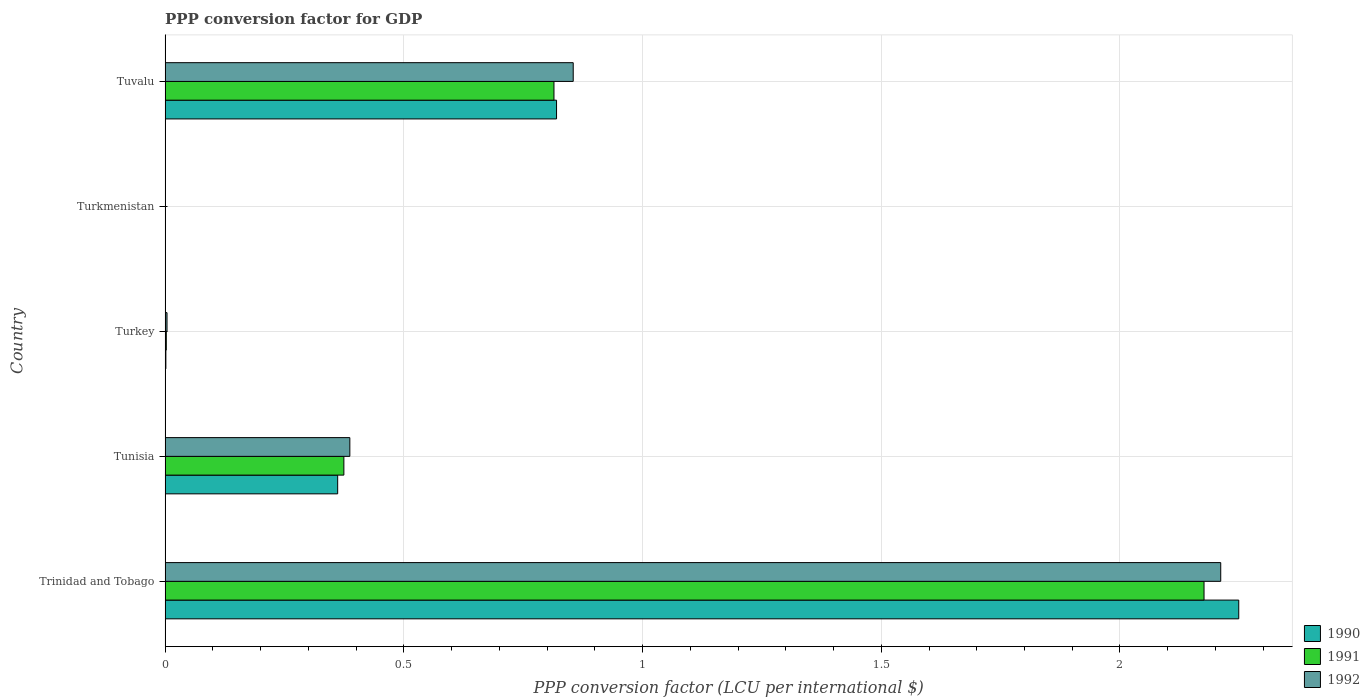How many different coloured bars are there?
Offer a very short reply. 3. Are the number of bars on each tick of the Y-axis equal?
Your answer should be very brief. Yes. How many bars are there on the 2nd tick from the top?
Ensure brevity in your answer.  3. What is the label of the 3rd group of bars from the top?
Make the answer very short. Turkey. What is the PPP conversion factor for GDP in 1991 in Tuvalu?
Ensure brevity in your answer.  0.81. Across all countries, what is the maximum PPP conversion factor for GDP in 1990?
Your response must be concise. 2.25. Across all countries, what is the minimum PPP conversion factor for GDP in 1990?
Provide a short and direct response. 1.53509362101671e-7. In which country was the PPP conversion factor for GDP in 1992 maximum?
Offer a terse response. Trinidad and Tobago. In which country was the PPP conversion factor for GDP in 1991 minimum?
Offer a very short reply. Turkmenistan. What is the total PPP conversion factor for GDP in 1991 in the graph?
Ensure brevity in your answer.  3.37. What is the difference between the PPP conversion factor for GDP in 1992 in Trinidad and Tobago and that in Turkmenistan?
Keep it short and to the point. 2.21. What is the difference between the PPP conversion factor for GDP in 1992 in Turkmenistan and the PPP conversion factor for GDP in 1990 in Turkey?
Provide a short and direct response. -0. What is the average PPP conversion factor for GDP in 1992 per country?
Offer a very short reply. 0.69. What is the difference between the PPP conversion factor for GDP in 1990 and PPP conversion factor for GDP in 1991 in Trinidad and Tobago?
Ensure brevity in your answer.  0.07. In how many countries, is the PPP conversion factor for GDP in 1991 greater than 1.5 LCU?
Give a very brief answer. 1. What is the ratio of the PPP conversion factor for GDP in 1991 in Trinidad and Tobago to that in Turkmenistan?
Ensure brevity in your answer.  7.22e+06. Is the PPP conversion factor for GDP in 1990 in Trinidad and Tobago less than that in Turkmenistan?
Make the answer very short. No. Is the difference between the PPP conversion factor for GDP in 1990 in Trinidad and Tobago and Tunisia greater than the difference between the PPP conversion factor for GDP in 1991 in Trinidad and Tobago and Tunisia?
Provide a succinct answer. Yes. What is the difference between the highest and the second highest PPP conversion factor for GDP in 1992?
Make the answer very short. 1.36. What is the difference between the highest and the lowest PPP conversion factor for GDP in 1991?
Make the answer very short. 2.18. In how many countries, is the PPP conversion factor for GDP in 1992 greater than the average PPP conversion factor for GDP in 1992 taken over all countries?
Offer a very short reply. 2. Is the sum of the PPP conversion factor for GDP in 1991 in Trinidad and Tobago and Turkmenistan greater than the maximum PPP conversion factor for GDP in 1990 across all countries?
Your answer should be very brief. No. What does the 1st bar from the top in Trinidad and Tobago represents?
Your answer should be compact. 1992. What does the 1st bar from the bottom in Trinidad and Tobago represents?
Offer a very short reply. 1990. How many bars are there?
Give a very brief answer. 15. Are all the bars in the graph horizontal?
Offer a very short reply. Yes. What is the difference between two consecutive major ticks on the X-axis?
Keep it short and to the point. 0.5. Are the values on the major ticks of X-axis written in scientific E-notation?
Provide a succinct answer. No. How are the legend labels stacked?
Give a very brief answer. Vertical. What is the title of the graph?
Offer a very short reply. PPP conversion factor for GDP. Does "1998" appear as one of the legend labels in the graph?
Ensure brevity in your answer.  No. What is the label or title of the X-axis?
Offer a terse response. PPP conversion factor (LCU per international $). What is the label or title of the Y-axis?
Your answer should be compact. Country. What is the PPP conversion factor (LCU per international $) in 1990 in Trinidad and Tobago?
Offer a very short reply. 2.25. What is the PPP conversion factor (LCU per international $) in 1991 in Trinidad and Tobago?
Offer a very short reply. 2.18. What is the PPP conversion factor (LCU per international $) of 1992 in Trinidad and Tobago?
Offer a very short reply. 2.21. What is the PPP conversion factor (LCU per international $) in 1990 in Tunisia?
Your response must be concise. 0.36. What is the PPP conversion factor (LCU per international $) of 1991 in Tunisia?
Provide a short and direct response. 0.37. What is the PPP conversion factor (LCU per international $) of 1992 in Tunisia?
Keep it short and to the point. 0.39. What is the PPP conversion factor (LCU per international $) of 1990 in Turkey?
Provide a succinct answer. 0. What is the PPP conversion factor (LCU per international $) of 1991 in Turkey?
Offer a terse response. 0. What is the PPP conversion factor (LCU per international $) of 1992 in Turkey?
Offer a very short reply. 0. What is the PPP conversion factor (LCU per international $) of 1990 in Turkmenistan?
Make the answer very short. 1.53509362101671e-7. What is the PPP conversion factor (LCU per international $) of 1991 in Turkmenistan?
Your response must be concise. 3.01227082389115e-7. What is the PPP conversion factor (LCU per international $) in 1992 in Turkmenistan?
Your answer should be compact. 9.4244319432505e-6. What is the PPP conversion factor (LCU per international $) in 1990 in Tuvalu?
Your answer should be compact. 0.82. What is the PPP conversion factor (LCU per international $) in 1991 in Tuvalu?
Give a very brief answer. 0.81. What is the PPP conversion factor (LCU per international $) of 1992 in Tuvalu?
Your response must be concise. 0.85. Across all countries, what is the maximum PPP conversion factor (LCU per international $) in 1990?
Provide a succinct answer. 2.25. Across all countries, what is the maximum PPP conversion factor (LCU per international $) of 1991?
Make the answer very short. 2.18. Across all countries, what is the maximum PPP conversion factor (LCU per international $) in 1992?
Provide a short and direct response. 2.21. Across all countries, what is the minimum PPP conversion factor (LCU per international $) of 1990?
Ensure brevity in your answer.  1.53509362101671e-7. Across all countries, what is the minimum PPP conversion factor (LCU per international $) in 1991?
Offer a terse response. 3.01227082389115e-7. Across all countries, what is the minimum PPP conversion factor (LCU per international $) in 1992?
Provide a succinct answer. 9.4244319432505e-6. What is the total PPP conversion factor (LCU per international $) of 1990 in the graph?
Your response must be concise. 3.43. What is the total PPP conversion factor (LCU per international $) in 1991 in the graph?
Offer a very short reply. 3.37. What is the total PPP conversion factor (LCU per international $) in 1992 in the graph?
Make the answer very short. 3.46. What is the difference between the PPP conversion factor (LCU per international $) in 1990 in Trinidad and Tobago and that in Tunisia?
Give a very brief answer. 1.89. What is the difference between the PPP conversion factor (LCU per international $) in 1991 in Trinidad and Tobago and that in Tunisia?
Provide a succinct answer. 1.8. What is the difference between the PPP conversion factor (LCU per international $) of 1992 in Trinidad and Tobago and that in Tunisia?
Your response must be concise. 1.82. What is the difference between the PPP conversion factor (LCU per international $) in 1990 in Trinidad and Tobago and that in Turkey?
Provide a succinct answer. 2.25. What is the difference between the PPP conversion factor (LCU per international $) in 1991 in Trinidad and Tobago and that in Turkey?
Your answer should be compact. 2.17. What is the difference between the PPP conversion factor (LCU per international $) of 1992 in Trinidad and Tobago and that in Turkey?
Offer a terse response. 2.21. What is the difference between the PPP conversion factor (LCU per international $) in 1990 in Trinidad and Tobago and that in Turkmenistan?
Offer a terse response. 2.25. What is the difference between the PPP conversion factor (LCU per international $) of 1991 in Trinidad and Tobago and that in Turkmenistan?
Give a very brief answer. 2.18. What is the difference between the PPP conversion factor (LCU per international $) of 1992 in Trinidad and Tobago and that in Turkmenistan?
Your answer should be compact. 2.21. What is the difference between the PPP conversion factor (LCU per international $) of 1990 in Trinidad and Tobago and that in Tuvalu?
Provide a short and direct response. 1.43. What is the difference between the PPP conversion factor (LCU per international $) in 1991 in Trinidad and Tobago and that in Tuvalu?
Give a very brief answer. 1.36. What is the difference between the PPP conversion factor (LCU per international $) in 1992 in Trinidad and Tobago and that in Tuvalu?
Offer a very short reply. 1.36. What is the difference between the PPP conversion factor (LCU per international $) of 1990 in Tunisia and that in Turkey?
Your answer should be very brief. 0.36. What is the difference between the PPP conversion factor (LCU per international $) in 1991 in Tunisia and that in Turkey?
Your answer should be compact. 0.37. What is the difference between the PPP conversion factor (LCU per international $) of 1992 in Tunisia and that in Turkey?
Offer a very short reply. 0.38. What is the difference between the PPP conversion factor (LCU per international $) in 1990 in Tunisia and that in Turkmenistan?
Provide a short and direct response. 0.36. What is the difference between the PPP conversion factor (LCU per international $) in 1991 in Tunisia and that in Turkmenistan?
Offer a terse response. 0.37. What is the difference between the PPP conversion factor (LCU per international $) in 1992 in Tunisia and that in Turkmenistan?
Offer a terse response. 0.39. What is the difference between the PPP conversion factor (LCU per international $) of 1990 in Tunisia and that in Tuvalu?
Give a very brief answer. -0.46. What is the difference between the PPP conversion factor (LCU per international $) of 1991 in Tunisia and that in Tuvalu?
Your answer should be compact. -0.44. What is the difference between the PPP conversion factor (LCU per international $) in 1992 in Tunisia and that in Tuvalu?
Give a very brief answer. -0.47. What is the difference between the PPP conversion factor (LCU per international $) in 1990 in Turkey and that in Turkmenistan?
Offer a terse response. 0. What is the difference between the PPP conversion factor (LCU per international $) of 1991 in Turkey and that in Turkmenistan?
Make the answer very short. 0. What is the difference between the PPP conversion factor (LCU per international $) in 1992 in Turkey and that in Turkmenistan?
Ensure brevity in your answer.  0. What is the difference between the PPP conversion factor (LCU per international $) in 1990 in Turkey and that in Tuvalu?
Give a very brief answer. -0.82. What is the difference between the PPP conversion factor (LCU per international $) in 1991 in Turkey and that in Tuvalu?
Provide a succinct answer. -0.81. What is the difference between the PPP conversion factor (LCU per international $) of 1992 in Turkey and that in Tuvalu?
Give a very brief answer. -0.85. What is the difference between the PPP conversion factor (LCU per international $) in 1990 in Turkmenistan and that in Tuvalu?
Provide a succinct answer. -0.82. What is the difference between the PPP conversion factor (LCU per international $) in 1991 in Turkmenistan and that in Tuvalu?
Your answer should be very brief. -0.81. What is the difference between the PPP conversion factor (LCU per international $) in 1992 in Turkmenistan and that in Tuvalu?
Offer a terse response. -0.85. What is the difference between the PPP conversion factor (LCU per international $) in 1990 in Trinidad and Tobago and the PPP conversion factor (LCU per international $) in 1991 in Tunisia?
Ensure brevity in your answer.  1.87. What is the difference between the PPP conversion factor (LCU per international $) of 1990 in Trinidad and Tobago and the PPP conversion factor (LCU per international $) of 1992 in Tunisia?
Provide a short and direct response. 1.86. What is the difference between the PPP conversion factor (LCU per international $) of 1991 in Trinidad and Tobago and the PPP conversion factor (LCU per international $) of 1992 in Tunisia?
Ensure brevity in your answer.  1.79. What is the difference between the PPP conversion factor (LCU per international $) in 1990 in Trinidad and Tobago and the PPP conversion factor (LCU per international $) in 1991 in Turkey?
Offer a very short reply. 2.25. What is the difference between the PPP conversion factor (LCU per international $) in 1990 in Trinidad and Tobago and the PPP conversion factor (LCU per international $) in 1992 in Turkey?
Ensure brevity in your answer.  2.24. What is the difference between the PPP conversion factor (LCU per international $) of 1991 in Trinidad and Tobago and the PPP conversion factor (LCU per international $) of 1992 in Turkey?
Your answer should be compact. 2.17. What is the difference between the PPP conversion factor (LCU per international $) in 1990 in Trinidad and Tobago and the PPP conversion factor (LCU per international $) in 1991 in Turkmenistan?
Provide a succinct answer. 2.25. What is the difference between the PPP conversion factor (LCU per international $) of 1990 in Trinidad and Tobago and the PPP conversion factor (LCU per international $) of 1992 in Turkmenistan?
Keep it short and to the point. 2.25. What is the difference between the PPP conversion factor (LCU per international $) of 1991 in Trinidad and Tobago and the PPP conversion factor (LCU per international $) of 1992 in Turkmenistan?
Your answer should be compact. 2.18. What is the difference between the PPP conversion factor (LCU per international $) of 1990 in Trinidad and Tobago and the PPP conversion factor (LCU per international $) of 1991 in Tuvalu?
Offer a terse response. 1.43. What is the difference between the PPP conversion factor (LCU per international $) of 1990 in Trinidad and Tobago and the PPP conversion factor (LCU per international $) of 1992 in Tuvalu?
Provide a short and direct response. 1.39. What is the difference between the PPP conversion factor (LCU per international $) of 1991 in Trinidad and Tobago and the PPP conversion factor (LCU per international $) of 1992 in Tuvalu?
Ensure brevity in your answer.  1.32. What is the difference between the PPP conversion factor (LCU per international $) in 1990 in Tunisia and the PPP conversion factor (LCU per international $) in 1991 in Turkey?
Ensure brevity in your answer.  0.36. What is the difference between the PPP conversion factor (LCU per international $) in 1990 in Tunisia and the PPP conversion factor (LCU per international $) in 1992 in Turkey?
Your answer should be very brief. 0.36. What is the difference between the PPP conversion factor (LCU per international $) in 1991 in Tunisia and the PPP conversion factor (LCU per international $) in 1992 in Turkey?
Offer a very short reply. 0.37. What is the difference between the PPP conversion factor (LCU per international $) of 1990 in Tunisia and the PPP conversion factor (LCU per international $) of 1991 in Turkmenistan?
Offer a terse response. 0.36. What is the difference between the PPP conversion factor (LCU per international $) in 1990 in Tunisia and the PPP conversion factor (LCU per international $) in 1992 in Turkmenistan?
Provide a succinct answer. 0.36. What is the difference between the PPP conversion factor (LCU per international $) in 1991 in Tunisia and the PPP conversion factor (LCU per international $) in 1992 in Turkmenistan?
Provide a succinct answer. 0.37. What is the difference between the PPP conversion factor (LCU per international $) in 1990 in Tunisia and the PPP conversion factor (LCU per international $) in 1991 in Tuvalu?
Keep it short and to the point. -0.45. What is the difference between the PPP conversion factor (LCU per international $) in 1990 in Tunisia and the PPP conversion factor (LCU per international $) in 1992 in Tuvalu?
Your answer should be compact. -0.49. What is the difference between the PPP conversion factor (LCU per international $) of 1991 in Tunisia and the PPP conversion factor (LCU per international $) of 1992 in Tuvalu?
Keep it short and to the point. -0.48. What is the difference between the PPP conversion factor (LCU per international $) in 1990 in Turkey and the PPP conversion factor (LCU per international $) in 1991 in Turkmenistan?
Keep it short and to the point. 0. What is the difference between the PPP conversion factor (LCU per international $) of 1990 in Turkey and the PPP conversion factor (LCU per international $) of 1992 in Turkmenistan?
Give a very brief answer. 0. What is the difference between the PPP conversion factor (LCU per international $) of 1991 in Turkey and the PPP conversion factor (LCU per international $) of 1992 in Turkmenistan?
Your response must be concise. 0. What is the difference between the PPP conversion factor (LCU per international $) in 1990 in Turkey and the PPP conversion factor (LCU per international $) in 1991 in Tuvalu?
Provide a succinct answer. -0.81. What is the difference between the PPP conversion factor (LCU per international $) of 1990 in Turkey and the PPP conversion factor (LCU per international $) of 1992 in Tuvalu?
Provide a succinct answer. -0.85. What is the difference between the PPP conversion factor (LCU per international $) in 1991 in Turkey and the PPP conversion factor (LCU per international $) in 1992 in Tuvalu?
Your answer should be very brief. -0.85. What is the difference between the PPP conversion factor (LCU per international $) of 1990 in Turkmenistan and the PPP conversion factor (LCU per international $) of 1991 in Tuvalu?
Make the answer very short. -0.81. What is the difference between the PPP conversion factor (LCU per international $) in 1990 in Turkmenistan and the PPP conversion factor (LCU per international $) in 1992 in Tuvalu?
Offer a very short reply. -0.85. What is the difference between the PPP conversion factor (LCU per international $) of 1991 in Turkmenistan and the PPP conversion factor (LCU per international $) of 1992 in Tuvalu?
Keep it short and to the point. -0.85. What is the average PPP conversion factor (LCU per international $) of 1990 per country?
Provide a succinct answer. 0.69. What is the average PPP conversion factor (LCU per international $) in 1991 per country?
Keep it short and to the point. 0.67. What is the average PPP conversion factor (LCU per international $) in 1992 per country?
Offer a very short reply. 0.69. What is the difference between the PPP conversion factor (LCU per international $) of 1990 and PPP conversion factor (LCU per international $) of 1991 in Trinidad and Tobago?
Ensure brevity in your answer.  0.07. What is the difference between the PPP conversion factor (LCU per international $) in 1990 and PPP conversion factor (LCU per international $) in 1992 in Trinidad and Tobago?
Ensure brevity in your answer.  0.04. What is the difference between the PPP conversion factor (LCU per international $) of 1991 and PPP conversion factor (LCU per international $) of 1992 in Trinidad and Tobago?
Provide a succinct answer. -0.04. What is the difference between the PPP conversion factor (LCU per international $) of 1990 and PPP conversion factor (LCU per international $) of 1991 in Tunisia?
Your answer should be very brief. -0.01. What is the difference between the PPP conversion factor (LCU per international $) of 1990 and PPP conversion factor (LCU per international $) of 1992 in Tunisia?
Make the answer very short. -0.03. What is the difference between the PPP conversion factor (LCU per international $) of 1991 and PPP conversion factor (LCU per international $) of 1992 in Tunisia?
Provide a succinct answer. -0.01. What is the difference between the PPP conversion factor (LCU per international $) of 1990 and PPP conversion factor (LCU per international $) of 1991 in Turkey?
Offer a terse response. -0. What is the difference between the PPP conversion factor (LCU per international $) of 1990 and PPP conversion factor (LCU per international $) of 1992 in Turkey?
Your response must be concise. -0. What is the difference between the PPP conversion factor (LCU per international $) of 1991 and PPP conversion factor (LCU per international $) of 1992 in Turkey?
Your response must be concise. -0. What is the difference between the PPP conversion factor (LCU per international $) in 1990 and PPP conversion factor (LCU per international $) in 1992 in Turkmenistan?
Your answer should be compact. -0. What is the difference between the PPP conversion factor (LCU per international $) in 1990 and PPP conversion factor (LCU per international $) in 1991 in Tuvalu?
Your response must be concise. 0.01. What is the difference between the PPP conversion factor (LCU per international $) of 1990 and PPP conversion factor (LCU per international $) of 1992 in Tuvalu?
Your response must be concise. -0.03. What is the difference between the PPP conversion factor (LCU per international $) of 1991 and PPP conversion factor (LCU per international $) of 1992 in Tuvalu?
Offer a terse response. -0.04. What is the ratio of the PPP conversion factor (LCU per international $) in 1990 in Trinidad and Tobago to that in Tunisia?
Give a very brief answer. 6.22. What is the ratio of the PPP conversion factor (LCU per international $) of 1991 in Trinidad and Tobago to that in Tunisia?
Provide a short and direct response. 5.81. What is the ratio of the PPP conversion factor (LCU per international $) in 1992 in Trinidad and Tobago to that in Tunisia?
Offer a terse response. 5.71. What is the ratio of the PPP conversion factor (LCU per international $) of 1990 in Trinidad and Tobago to that in Turkey?
Your answer should be compact. 1372.88. What is the ratio of the PPP conversion factor (LCU per international $) of 1991 in Trinidad and Tobago to that in Turkey?
Your answer should be very brief. 864.21. What is the ratio of the PPP conversion factor (LCU per international $) of 1992 in Trinidad and Tobago to that in Turkey?
Provide a succinct answer. 548.64. What is the ratio of the PPP conversion factor (LCU per international $) of 1990 in Trinidad and Tobago to that in Turkmenistan?
Offer a very short reply. 1.46e+07. What is the ratio of the PPP conversion factor (LCU per international $) in 1991 in Trinidad and Tobago to that in Turkmenistan?
Offer a terse response. 7.22e+06. What is the ratio of the PPP conversion factor (LCU per international $) of 1992 in Trinidad and Tobago to that in Turkmenistan?
Your answer should be very brief. 2.35e+05. What is the ratio of the PPP conversion factor (LCU per international $) of 1990 in Trinidad and Tobago to that in Tuvalu?
Your answer should be very brief. 2.74. What is the ratio of the PPP conversion factor (LCU per international $) of 1991 in Trinidad and Tobago to that in Tuvalu?
Provide a succinct answer. 2.67. What is the ratio of the PPP conversion factor (LCU per international $) of 1992 in Trinidad and Tobago to that in Tuvalu?
Ensure brevity in your answer.  2.59. What is the ratio of the PPP conversion factor (LCU per international $) in 1990 in Tunisia to that in Turkey?
Make the answer very short. 220.68. What is the ratio of the PPP conversion factor (LCU per international $) of 1991 in Tunisia to that in Turkey?
Give a very brief answer. 148.71. What is the ratio of the PPP conversion factor (LCU per international $) of 1992 in Tunisia to that in Turkey?
Offer a terse response. 96.01. What is the ratio of the PPP conversion factor (LCU per international $) in 1990 in Tunisia to that in Turkmenistan?
Make the answer very short. 2.35e+06. What is the ratio of the PPP conversion factor (LCU per international $) of 1991 in Tunisia to that in Turkmenistan?
Make the answer very short. 1.24e+06. What is the ratio of the PPP conversion factor (LCU per international $) of 1992 in Tunisia to that in Turkmenistan?
Your answer should be compact. 4.11e+04. What is the ratio of the PPP conversion factor (LCU per international $) in 1990 in Tunisia to that in Tuvalu?
Give a very brief answer. 0.44. What is the ratio of the PPP conversion factor (LCU per international $) in 1991 in Tunisia to that in Tuvalu?
Keep it short and to the point. 0.46. What is the ratio of the PPP conversion factor (LCU per international $) of 1992 in Tunisia to that in Tuvalu?
Give a very brief answer. 0.45. What is the ratio of the PPP conversion factor (LCU per international $) of 1990 in Turkey to that in Turkmenistan?
Offer a terse response. 1.07e+04. What is the ratio of the PPP conversion factor (LCU per international $) in 1991 in Turkey to that in Turkmenistan?
Provide a succinct answer. 8359.14. What is the ratio of the PPP conversion factor (LCU per international $) in 1992 in Turkey to that in Turkmenistan?
Keep it short and to the point. 427.61. What is the ratio of the PPP conversion factor (LCU per international $) in 1990 in Turkey to that in Tuvalu?
Your answer should be compact. 0. What is the ratio of the PPP conversion factor (LCU per international $) in 1991 in Turkey to that in Tuvalu?
Give a very brief answer. 0. What is the ratio of the PPP conversion factor (LCU per international $) of 1992 in Turkey to that in Tuvalu?
Provide a short and direct response. 0. What is the difference between the highest and the second highest PPP conversion factor (LCU per international $) of 1990?
Offer a very short reply. 1.43. What is the difference between the highest and the second highest PPP conversion factor (LCU per international $) of 1991?
Your answer should be very brief. 1.36. What is the difference between the highest and the second highest PPP conversion factor (LCU per international $) of 1992?
Ensure brevity in your answer.  1.36. What is the difference between the highest and the lowest PPP conversion factor (LCU per international $) in 1990?
Give a very brief answer. 2.25. What is the difference between the highest and the lowest PPP conversion factor (LCU per international $) of 1991?
Offer a terse response. 2.18. What is the difference between the highest and the lowest PPP conversion factor (LCU per international $) in 1992?
Make the answer very short. 2.21. 